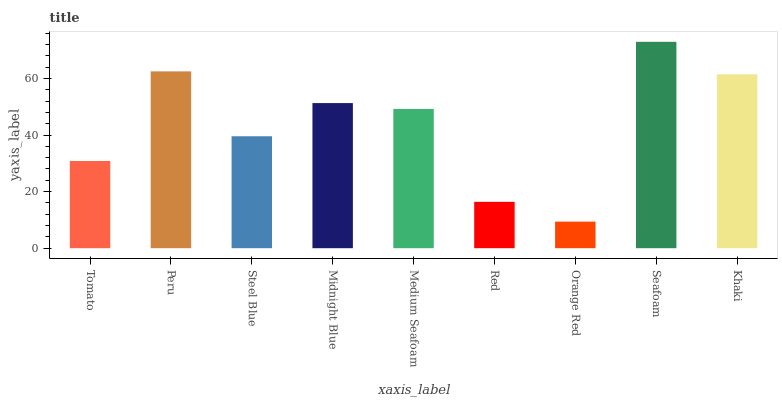Is Peru the minimum?
Answer yes or no. No. Is Peru the maximum?
Answer yes or no. No. Is Peru greater than Tomato?
Answer yes or no. Yes. Is Tomato less than Peru?
Answer yes or no. Yes. Is Tomato greater than Peru?
Answer yes or no. No. Is Peru less than Tomato?
Answer yes or no. No. Is Medium Seafoam the high median?
Answer yes or no. Yes. Is Medium Seafoam the low median?
Answer yes or no. Yes. Is Seafoam the high median?
Answer yes or no. No. Is Red the low median?
Answer yes or no. No. 